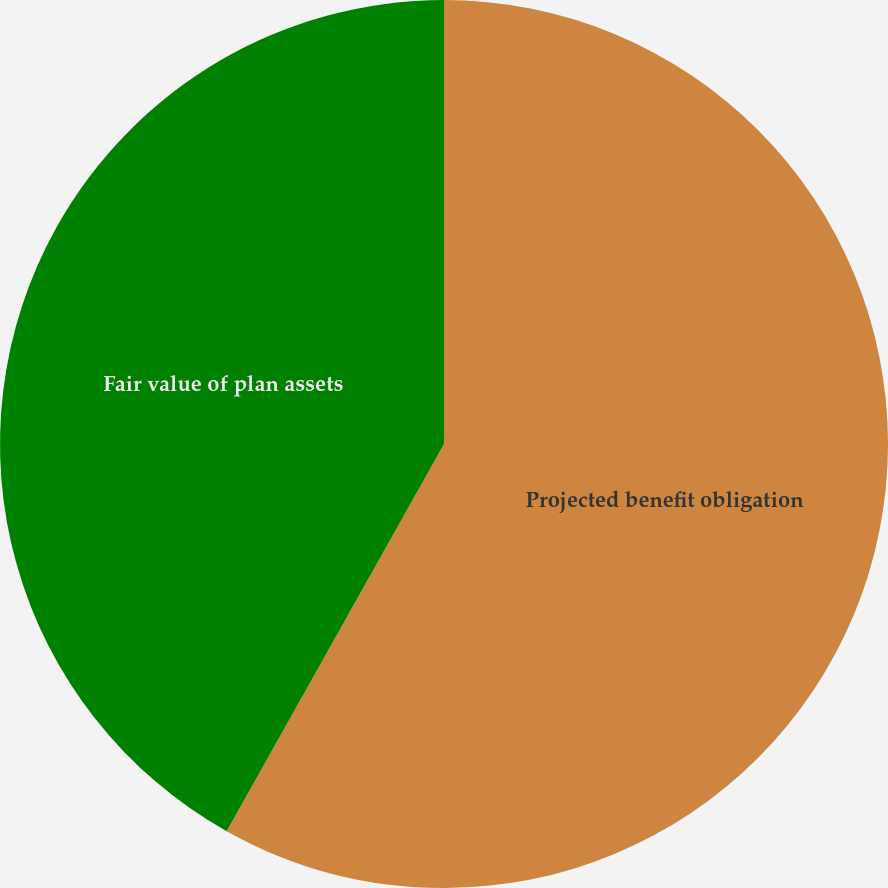Convert chart to OTSL. <chart><loc_0><loc_0><loc_500><loc_500><pie_chart><fcel>Projected benefit obligation<fcel>Fair value of plan assets<nl><fcel>58.14%<fcel>41.86%<nl></chart> 